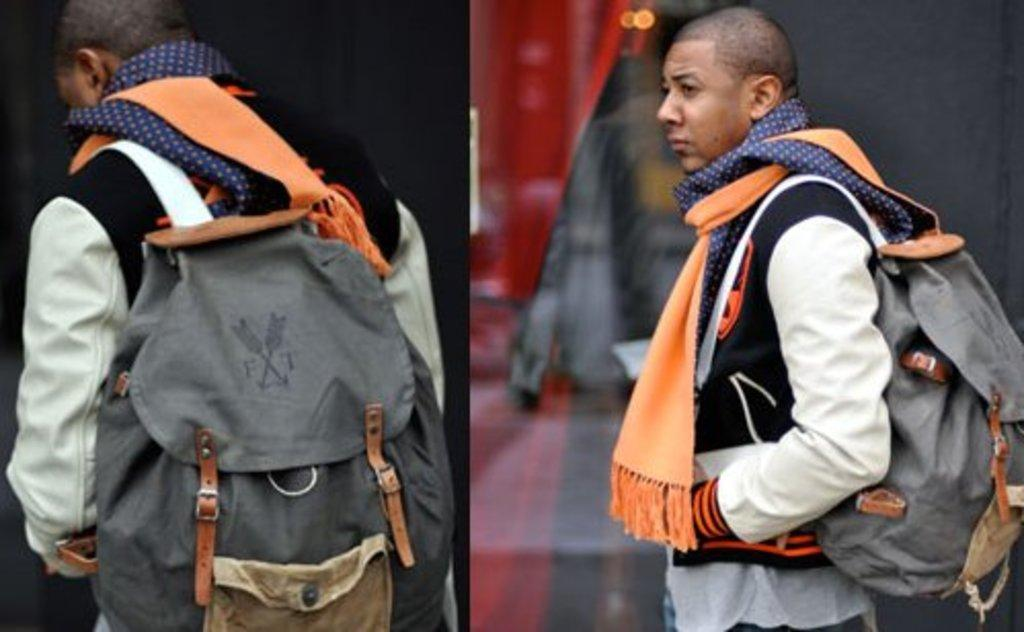Provide a one-sentence caption for the provided image. A posh fellow with many scarves carrying an FT backpack. 